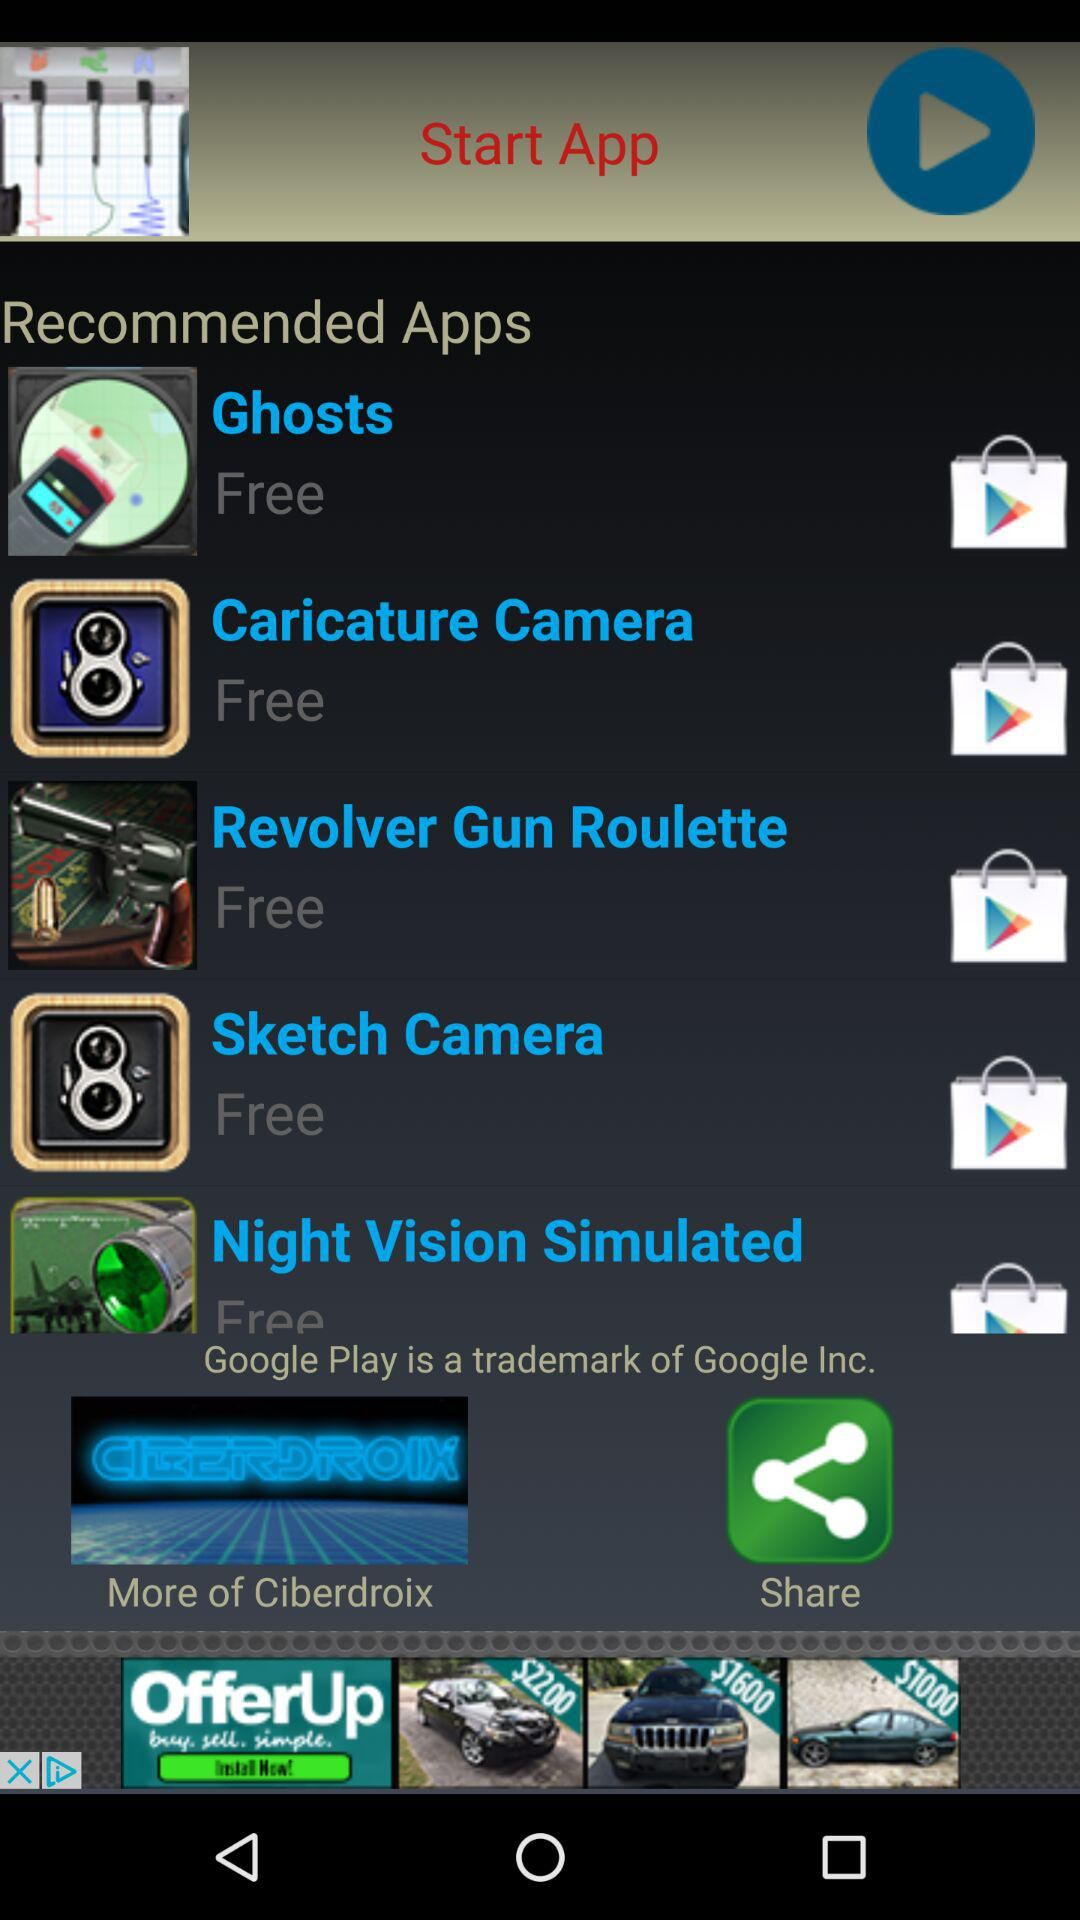What are the names of the applications that are free? The names of the applications that are free are "Ghosts", "Caricature Camera", "Revolver Gun Roulette", "Sketch Camera" and "Night Vision Simulated". 